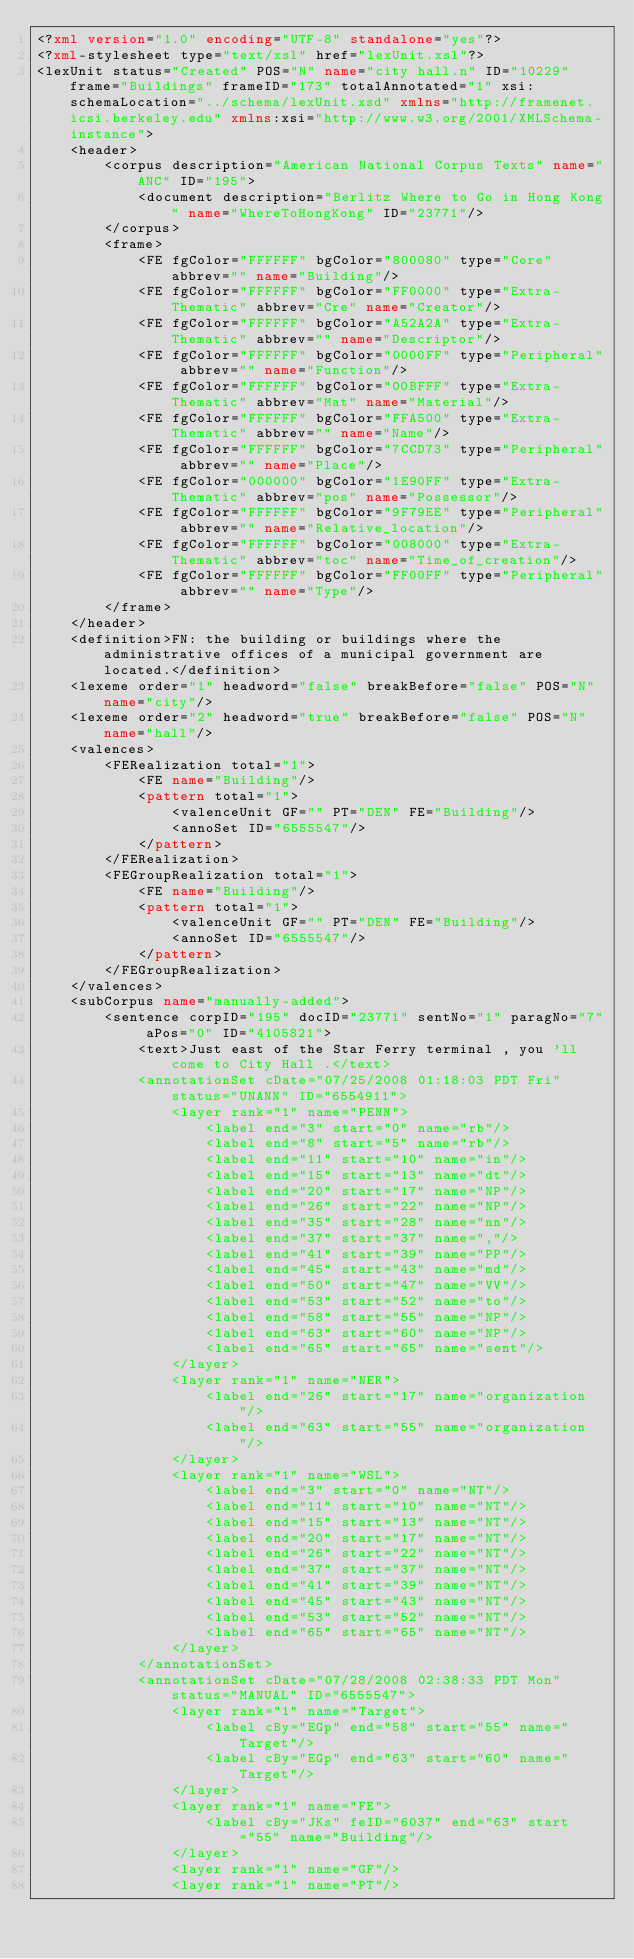<code> <loc_0><loc_0><loc_500><loc_500><_XML_><?xml version="1.0" encoding="UTF-8" standalone="yes"?>
<?xml-stylesheet type="text/xsl" href="lexUnit.xsl"?>
<lexUnit status="Created" POS="N" name="city hall.n" ID="10229" frame="Buildings" frameID="173" totalAnnotated="1" xsi:schemaLocation="../schema/lexUnit.xsd" xmlns="http://framenet.icsi.berkeley.edu" xmlns:xsi="http://www.w3.org/2001/XMLSchema-instance">
    <header>
        <corpus description="American National Corpus Texts" name="ANC" ID="195">
            <document description="Berlitz Where to Go in Hong Kong" name="WhereToHongKong" ID="23771"/>
        </corpus>
        <frame>
            <FE fgColor="FFFFFF" bgColor="800080" type="Core" abbrev="" name="Building"/>
            <FE fgColor="FFFFFF" bgColor="FF0000" type="Extra-Thematic" abbrev="Cre" name="Creator"/>
            <FE fgColor="FFFFFF" bgColor="A52A2A" type="Extra-Thematic" abbrev="" name="Descriptor"/>
            <FE fgColor="FFFFFF" bgColor="0000FF" type="Peripheral" abbrev="" name="Function"/>
            <FE fgColor="FFFFFF" bgColor="00BFFF" type="Extra-Thematic" abbrev="Mat" name="Material"/>
            <FE fgColor="FFFFFF" bgColor="FFA500" type="Extra-Thematic" abbrev="" name="Name"/>
            <FE fgColor="FFFFFF" bgColor="7CCD73" type="Peripheral" abbrev="" name="Place"/>
            <FE fgColor="000000" bgColor="1E90FF" type="Extra-Thematic" abbrev="pos" name="Possessor"/>
            <FE fgColor="FFFFFF" bgColor="9F79EE" type="Peripheral" abbrev="" name="Relative_location"/>
            <FE fgColor="FFFFFF" bgColor="008000" type="Extra-Thematic" abbrev="toc" name="Time_of_creation"/>
            <FE fgColor="FFFFFF" bgColor="FF00FF" type="Peripheral" abbrev="" name="Type"/>
        </frame>
    </header>
    <definition>FN: the building or buildings where the administrative offices of a municipal government are located.</definition>
    <lexeme order="1" headword="false" breakBefore="false" POS="N" name="city"/>
    <lexeme order="2" headword="true" breakBefore="false" POS="N" name="hall"/>
    <valences>
        <FERealization total="1">
            <FE name="Building"/>
            <pattern total="1">
                <valenceUnit GF="" PT="DEN" FE="Building"/>
                <annoSet ID="6555547"/>
            </pattern>
        </FERealization>
        <FEGroupRealization total="1">
            <FE name="Building"/>
            <pattern total="1">
                <valenceUnit GF="" PT="DEN" FE="Building"/>
                <annoSet ID="6555547"/>
            </pattern>
        </FEGroupRealization>
    </valences>
    <subCorpus name="manually-added">
        <sentence corpID="195" docID="23771" sentNo="1" paragNo="7" aPos="0" ID="4105821">
            <text>Just east of the Star Ferry terminal , you 'll come to City Hall .</text>
            <annotationSet cDate="07/25/2008 01:18:03 PDT Fri" status="UNANN" ID="6554911">
                <layer rank="1" name="PENN">
                    <label end="3" start="0" name="rb"/>
                    <label end="8" start="5" name="rb"/>
                    <label end="11" start="10" name="in"/>
                    <label end="15" start="13" name="dt"/>
                    <label end="20" start="17" name="NP"/>
                    <label end="26" start="22" name="NP"/>
                    <label end="35" start="28" name="nn"/>
                    <label end="37" start="37" name=","/>
                    <label end="41" start="39" name="PP"/>
                    <label end="45" start="43" name="md"/>
                    <label end="50" start="47" name="VV"/>
                    <label end="53" start="52" name="to"/>
                    <label end="58" start="55" name="NP"/>
                    <label end="63" start="60" name="NP"/>
                    <label end="65" start="65" name="sent"/>
                </layer>
                <layer rank="1" name="NER">
                    <label end="26" start="17" name="organization"/>
                    <label end="63" start="55" name="organization"/>
                </layer>
                <layer rank="1" name="WSL">
                    <label end="3" start="0" name="NT"/>
                    <label end="11" start="10" name="NT"/>
                    <label end="15" start="13" name="NT"/>
                    <label end="20" start="17" name="NT"/>
                    <label end="26" start="22" name="NT"/>
                    <label end="37" start="37" name="NT"/>
                    <label end="41" start="39" name="NT"/>
                    <label end="45" start="43" name="NT"/>
                    <label end="53" start="52" name="NT"/>
                    <label end="65" start="65" name="NT"/>
                </layer>
            </annotationSet>
            <annotationSet cDate="07/28/2008 02:38:33 PDT Mon" status="MANUAL" ID="6555547">
                <layer rank="1" name="Target">
                    <label cBy="EGp" end="58" start="55" name="Target"/>
                    <label cBy="EGp" end="63" start="60" name="Target"/>
                </layer>
                <layer rank="1" name="FE">
                    <label cBy="JKs" feID="6037" end="63" start="55" name="Building"/>
                </layer>
                <layer rank="1" name="GF"/>
                <layer rank="1" name="PT"/></code> 